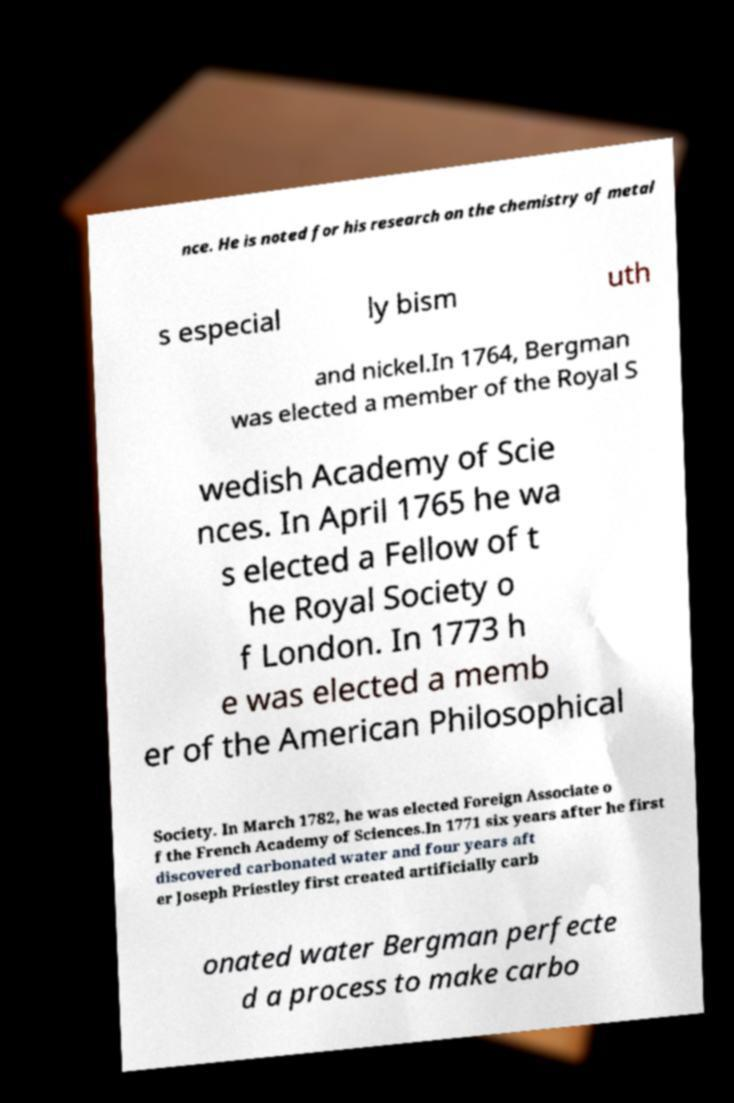Can you read and provide the text displayed in the image?This photo seems to have some interesting text. Can you extract and type it out for me? nce. He is noted for his research on the chemistry of metal s especial ly bism uth and nickel.In 1764, Bergman was elected a member of the Royal S wedish Academy of Scie nces. In April 1765 he wa s elected a Fellow of t he Royal Society o f London. In 1773 h e was elected a memb er of the American Philosophical Society. In March 1782, he was elected Foreign Associate o f the French Academy of Sciences.In 1771 six years after he first discovered carbonated water and four years aft er Joseph Priestley first created artificially carb onated water Bergman perfecte d a process to make carbo 